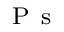<formula> <loc_0><loc_0><loc_500><loc_500>_ { P s }</formula> 